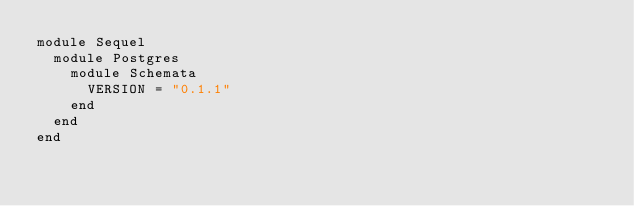Convert code to text. <code><loc_0><loc_0><loc_500><loc_500><_Ruby_>module Sequel
  module Postgres
    module Schemata
      VERSION = "0.1.1"
    end
  end
end
</code> 